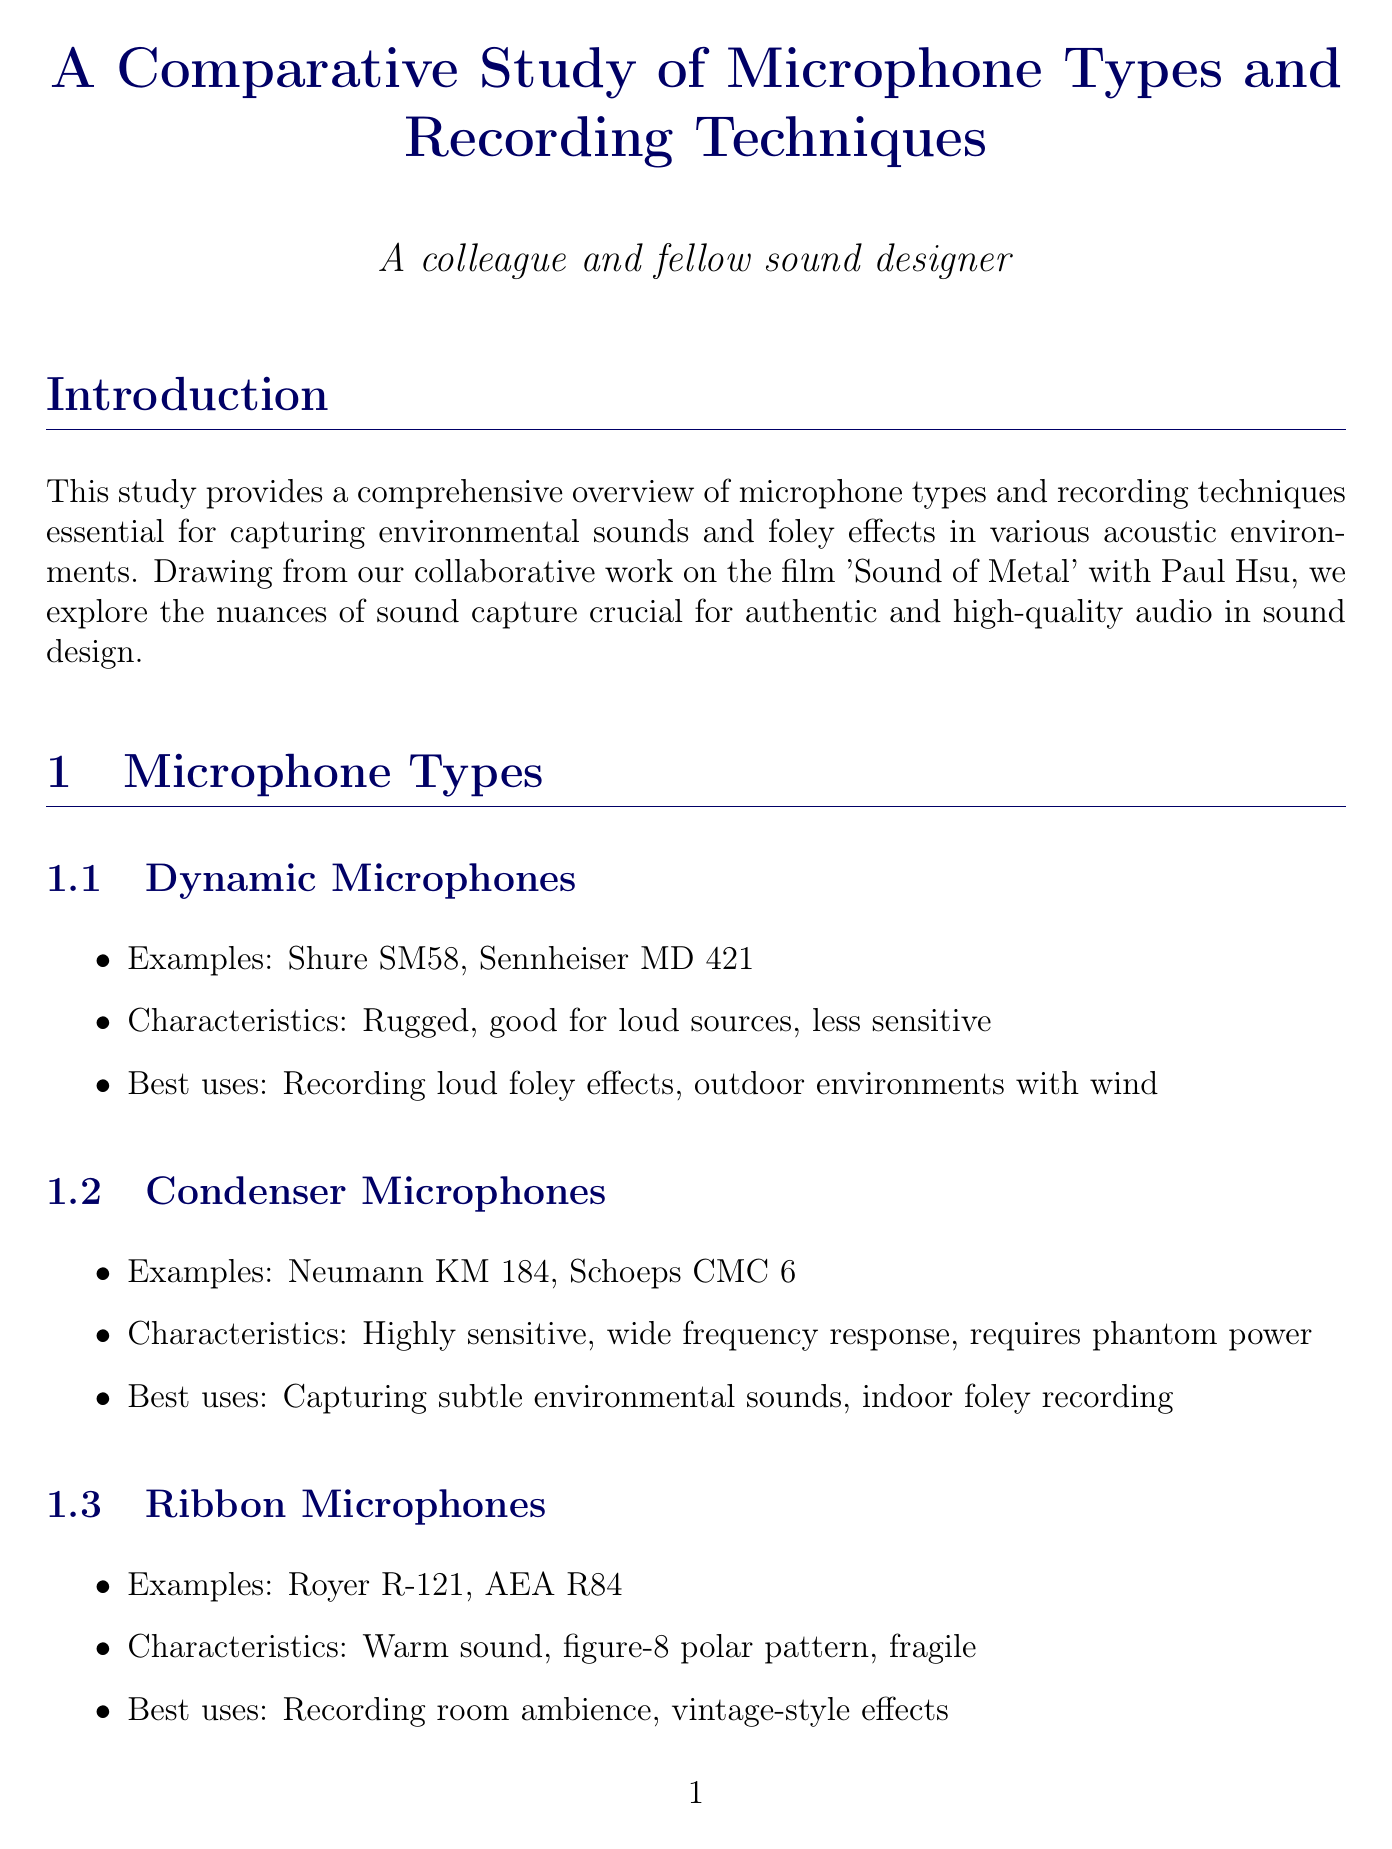What is the main focus of the study? The study provides a comprehensive overview of microphone types and recording techniques essential for capturing environmental sounds and foley effects.
Answer: Capturing environmental sounds and foley effects Which microphone type is described as fragile and has a figure-8 polar pattern? The characteristics and best uses of each microphone type help in identifying them based on their unique features.
Answer: Ribbon microphones What recording technique uses three microphones for a compact surround setup? The document describes various recording techniques and their specific methods, such as the double M-S technique.
Answer: Double M-S What are the challenges in recording outdoor locations? The document lists specific challenges faced in different acoustic environments, including outdoor recordings.
Answer: Wind noise, unwanted background sounds, varying acoustic reflections In the film "Sound of Metal," what was a key technique used? The case studies section highlights specific techniques utilized in various projects, particularly in the mentioned film.
Answer: Binaural recording for POV scenes What type of microphones are used for capturing marine life in documentaries? The document discusses unique locations and the equipment suitable for those environments, specifically underwater recordings.
Answer: Underwater hydrophones What is one of the future trends mentioned in the document? The document lists trends affecting sound design, focusing on advancements in audio technology.
Answer: Immersive audio How does the document suggest overcoming HVAC noise in indoor locations? The solutions proposed for dealing with challenges are important details covered in the acoustic environment section.
Answer: Acoustic treatment, strategic mic placement, use of gobos and baffles Which microphone examples are provided for shotgun microphones? The examples of specific microphone types serve as references for sound designers looking for appropriate equipment.
Answer: Sennheiser MKH 416, Rode NTG3 What is the importance of choosing the right microphone mentioned in the conclusion? The key takeaways in the conclusion summarize essential considerations in sound design practices.
Answer: Importance of choosing the right microphone for the task 